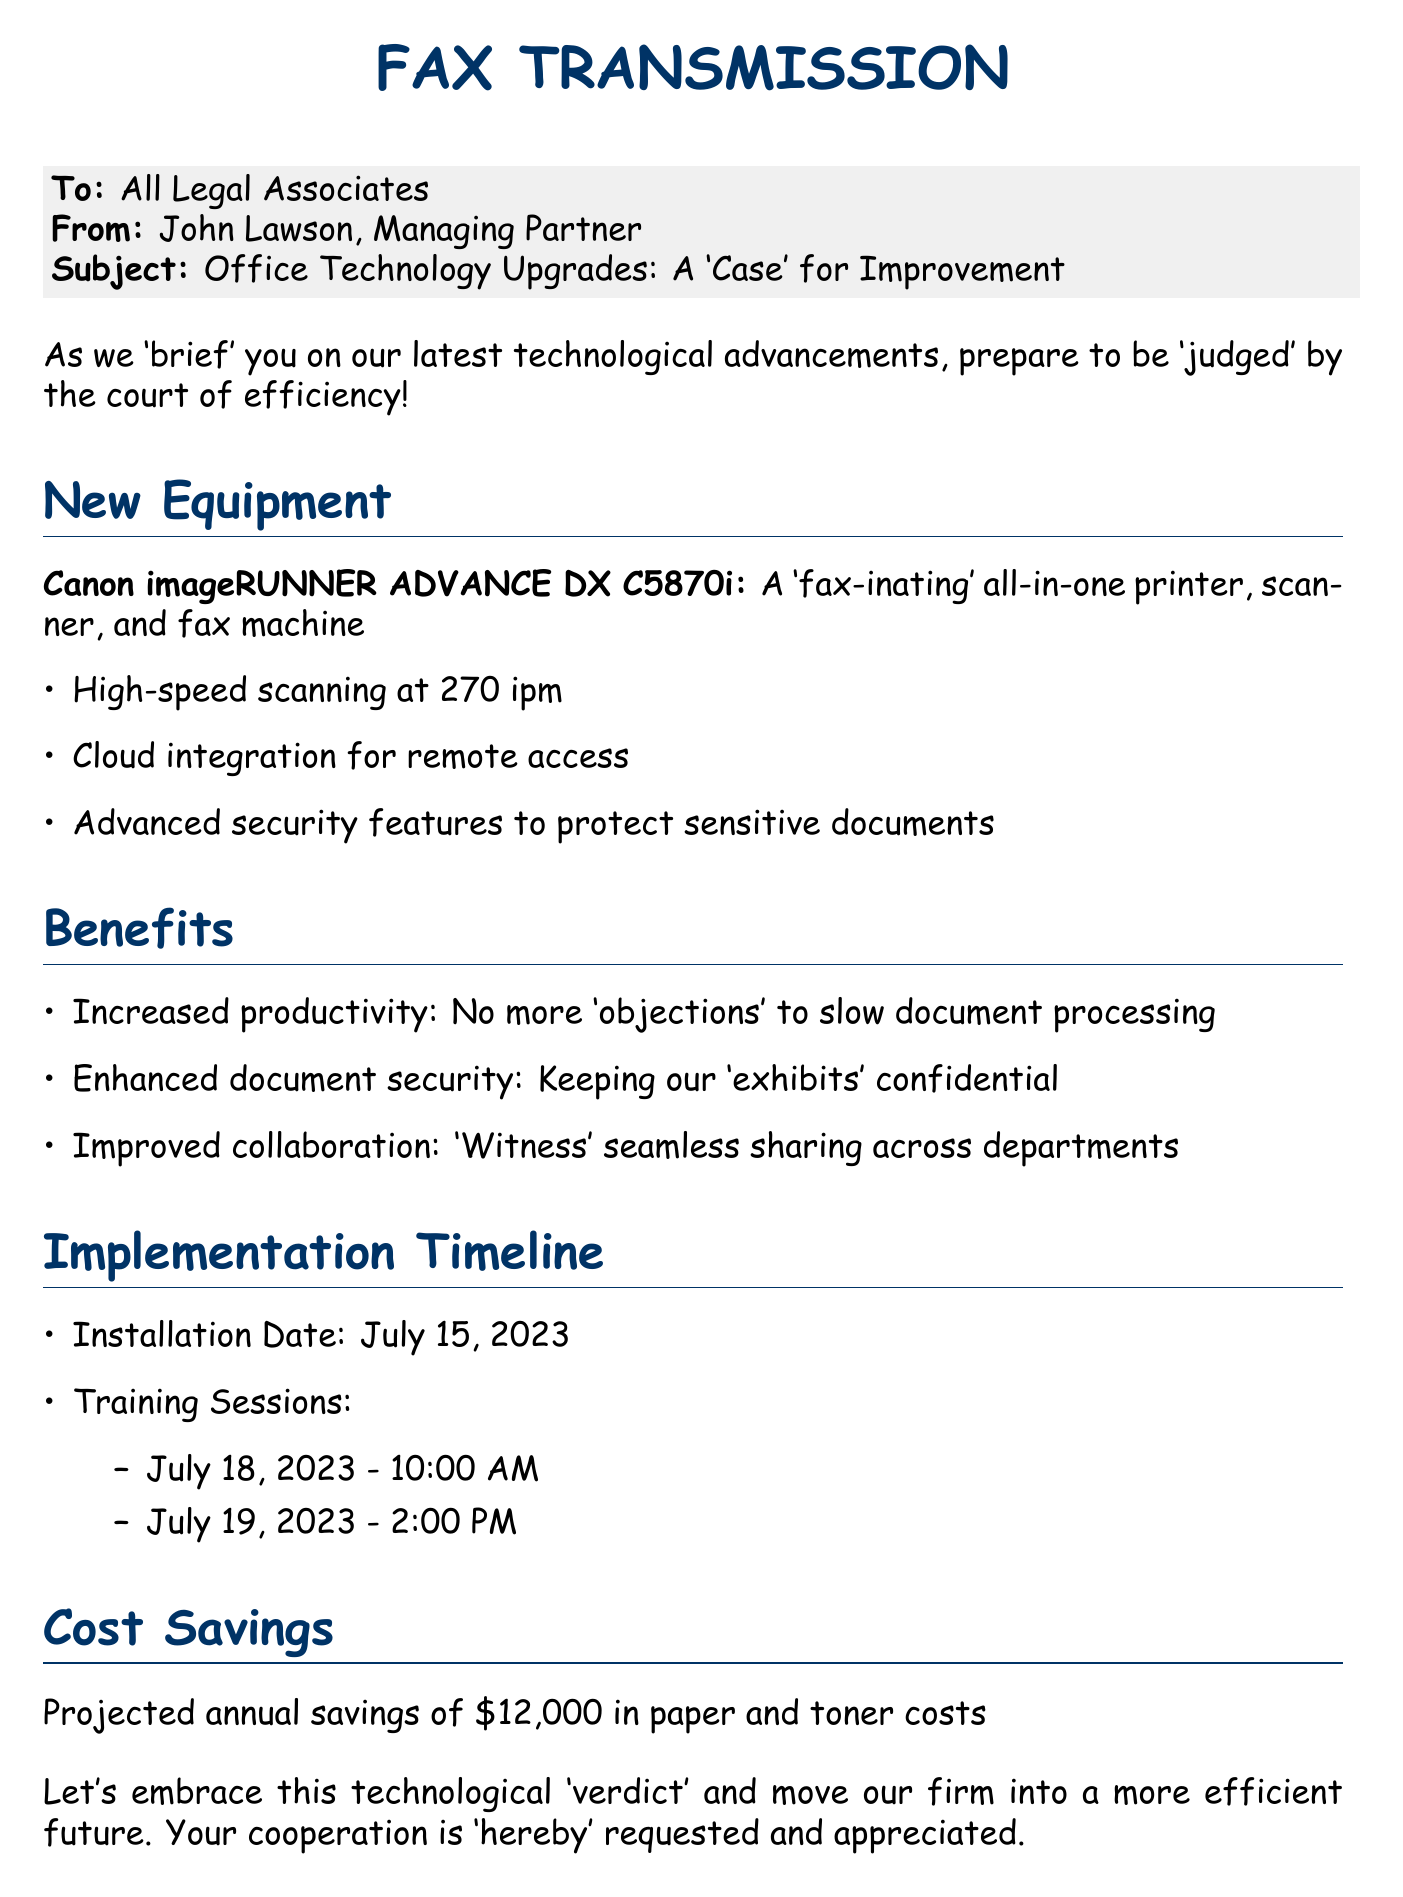What is the date of the installation? The installation date is mentioned under the implementation timeline section, which states July 15, 2023.
Answer: July 15, 2023 Who is the sender of the fax? The sender's name is found in the "From" line, which states John Lawson, Managing Partner.
Answer: John Lawson What is the projected annual savings? The projected savings is stated towards the end of the document, which mentions a savings of $12,000.
Answer: $12,000 What type of machine is being introduced? The machine type is specified at the beginning of the new equipment section, stating it is a Canon imageRUNNER ADVANCE DX C5870i.
Answer: Canon imageRUNNER ADVANCE DX C5870i When are the training sessions scheduled? The training sessions are detailed in the implementation timeline, specifically set for July 18 and July 19, 2023.
Answer: July 18 and July 19, 2023 What are the benefits of the new equipment? The benefits are listed in a section that highlights increased productivity, enhanced document security, and improved collaboration.
Answer: Increased productivity, enhanced document security, improved collaboration What unique feature does the new machine have? The machine's unique feature mentioned is high-speed scanning at 270 ipm.
Answer: High-speed scanning at 270 ipm What color identifies the main headers? The color used for the main headers is specified as lawyerblue in the document.
Answer: lawyerblue 